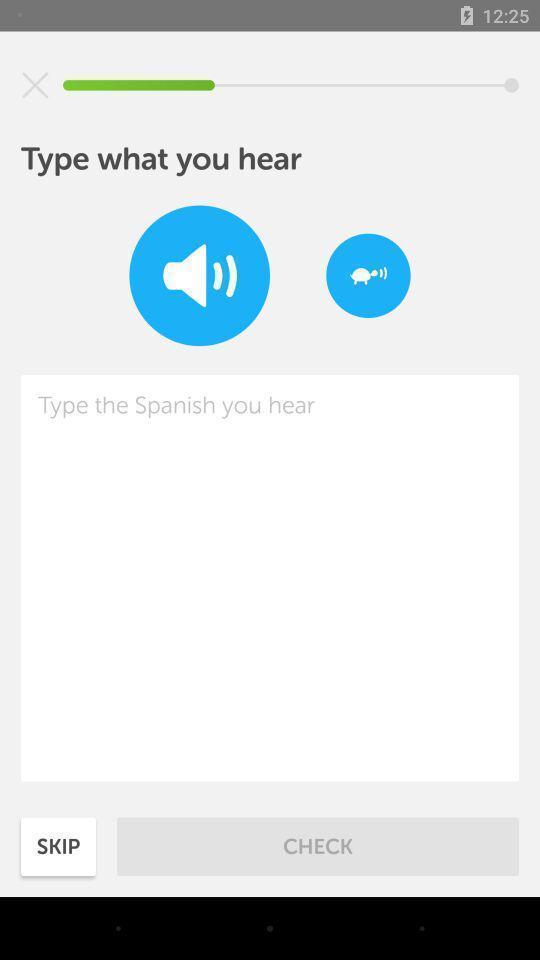Summarize the main components in this picture. Page with type what you hear in language learning app. 